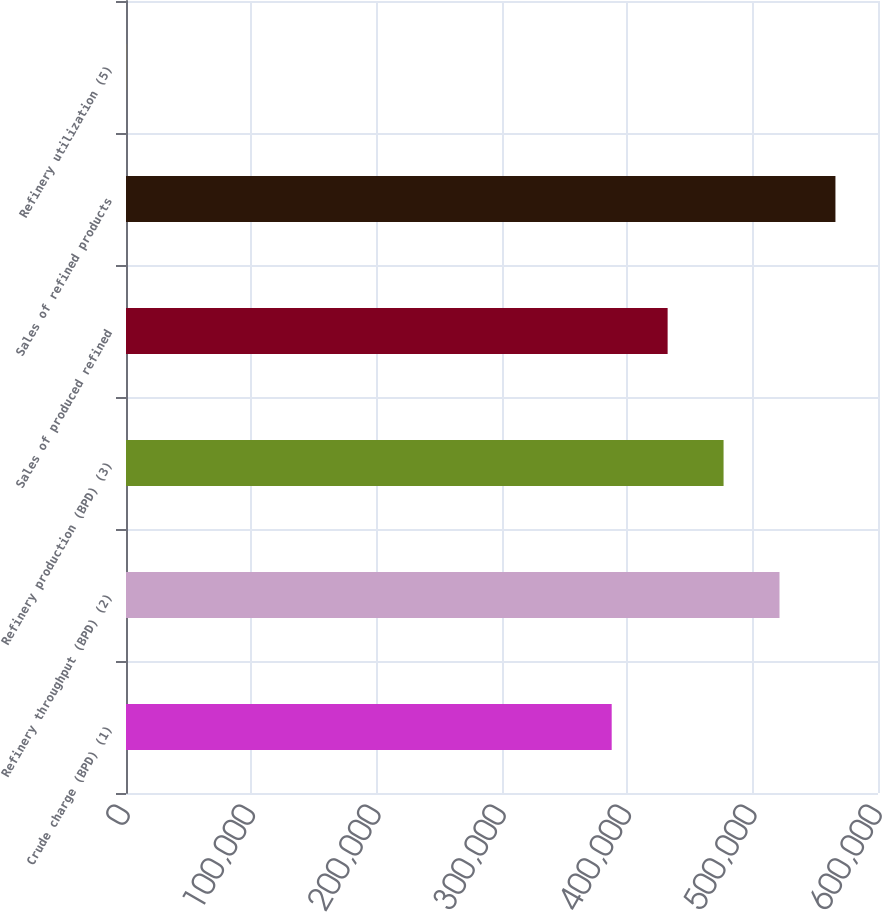Convert chart. <chart><loc_0><loc_0><loc_500><loc_500><bar_chart><fcel>Crude charge (BPD) (1)<fcel>Refinery throughput (BPD) (2)<fcel>Refinery production (BPD) (3)<fcel>Sales of produced refined<fcel>Sales of refined products<fcel>Refinery utilization (5)<nl><fcel>387520<fcel>521411<fcel>476780<fcel>432150<fcel>566041<fcel>87.5<nl></chart> 